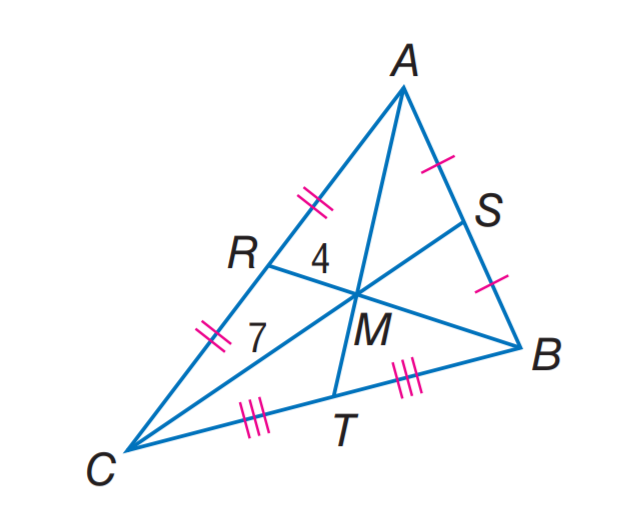Answer the mathemtical geometry problem and directly provide the correct option letter.
Question: M C = 7, R M = 4, and A T = 16. Find S C.
Choices: A: 10.5 B: 12 C: 13.5 D: 21 A 